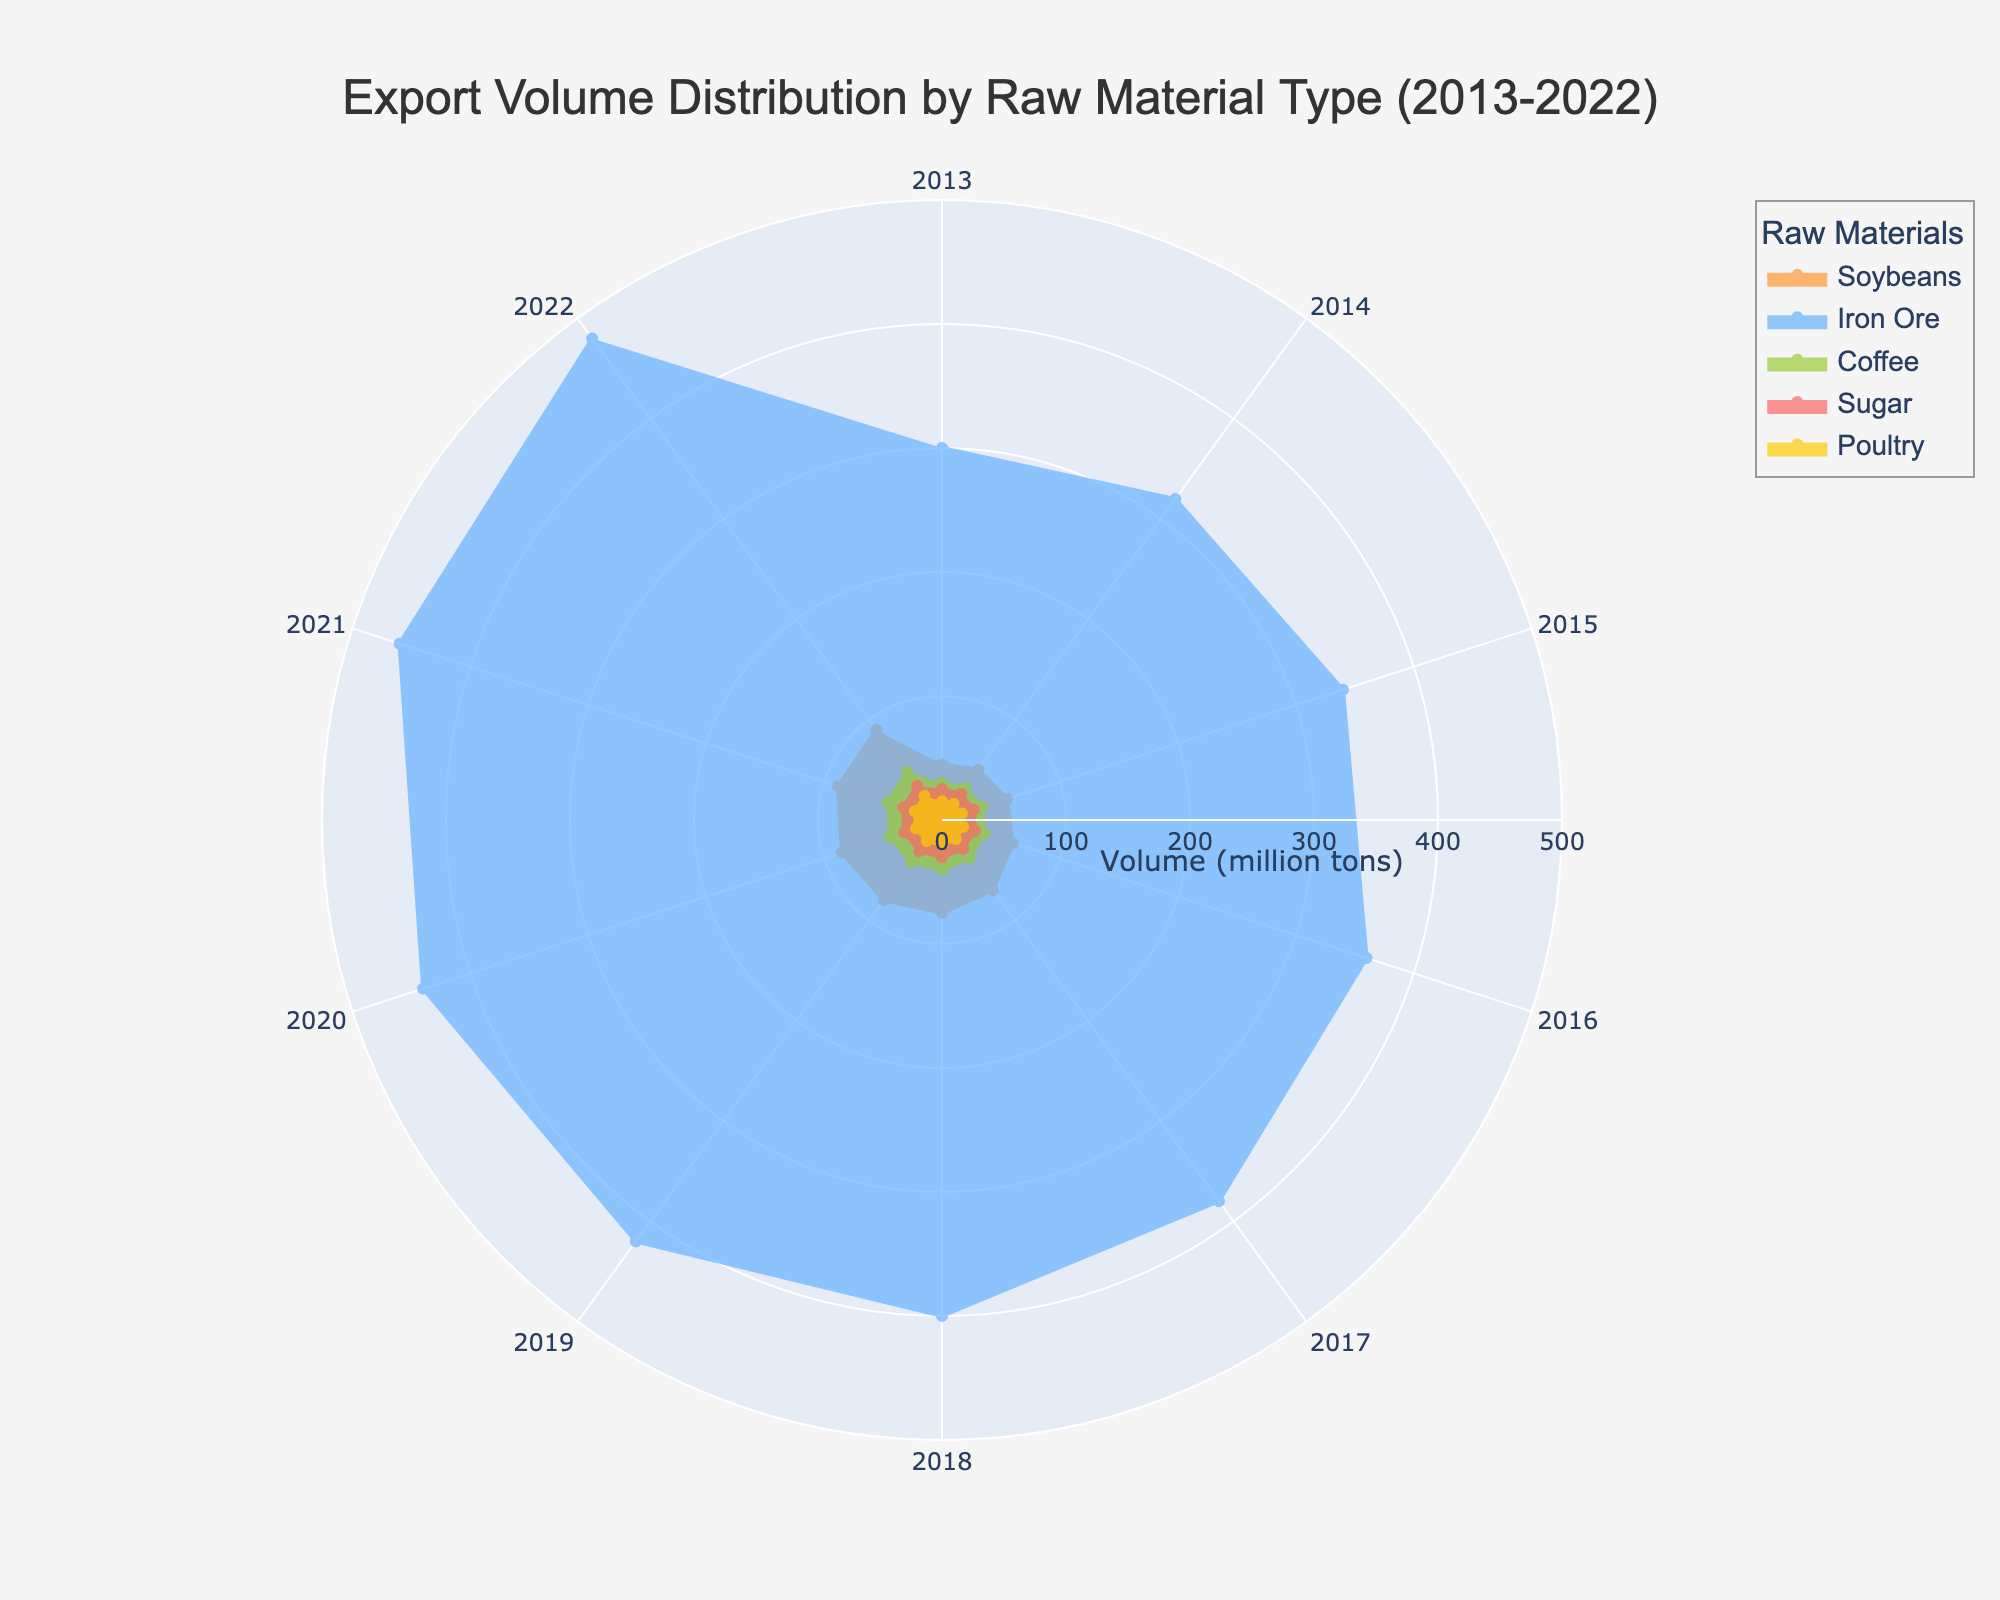What is the title of the figure? The title of the figure is usually prominently displayed at the top center of the chart. It helps in quickly identifying the subject of the chart. For this figure, the title reads "Export Volume Distribution by Raw Material Type (2013-2022)".
Answer: Export Volume Distribution by Raw Material Type (2013-2022) Which raw material had the highest export volume in 2022? One needs to look at the 2022 data points for all materials and identify which one is the farthest from the center. The export volume of Iron Ore is the highest in 2022, reaching 480 million tons.
Answer: Iron Ore What is the color used to represent Soybeans? Colors distinguish different materials in the polar area chart. The color corresponding to Soybeans is usually identified through the legend. For Soybeans, the color used in this chart is a shade of orange.
Answer: Orange How has the export volume of Coffee changed from 2013 to 2022? By observing the data points for Coffee from 2013 to 2022, one can see a gradual increase. In 2013, Coffee had a volume of 30 million tons and this progressively increased each year to 48 million tons in 2022.
Answer: Increased from 30 million tons to 48 million tons What is the difference in export volume between Iron Ore and Coffee in 2020? To find the difference, locate the 2020 data points for both Iron Ore and Coffee. Iron Ore's volume in 2020 was 440 million tons, and Coffee's was 44 million tons. The difference is calculated as 440 - 44 = 396 million tons.
Answer: 396 million tons Which raw material shows a consistent increase in export volume over the decade? By examining the trends for all raw materials displayed in the chart, one can see that all materials—Soybeans, Iron Ore, Coffee, Sugar, and Poultry—show a consistent increase in export volume from 2013 to 2022.
Answer: All raw materials (Soybeans, Iron Ore, Coffee, Sugar, Poultry) How does the export volume of Sugar in 2015 compare to that in 2020? To compare, look at the export volumes for Sugar in 2015 and 2020. In 2015, the volume was 27 million tons and by 2020, it increased to 32 million tons. So, the volume in 2020 is greater by 5 million tons than in 2015.
Answer: Volume in 2020 is 5 million tons greater than in 2015 What is the average export volume of Poultry from 2013 to 2022? Calculate the average by summing the export volumes for Poultry across all years from 2013 to 2022 and then dividing by the number of years. The volumes are 15, 16, 17, 18, 19, 20, 21, 22, 23, 24. The sum is 195, and the average is 195 / 10 = 19.5 million tons.
Answer: 19.5 million tons In which year did the export volume of Iron Ore first surpass 400 million tons? By tracing the data points for Iron Ore, it can be observed that the export volume surpasses 400 million tons for the first time in 2018.
Answer: 2018 